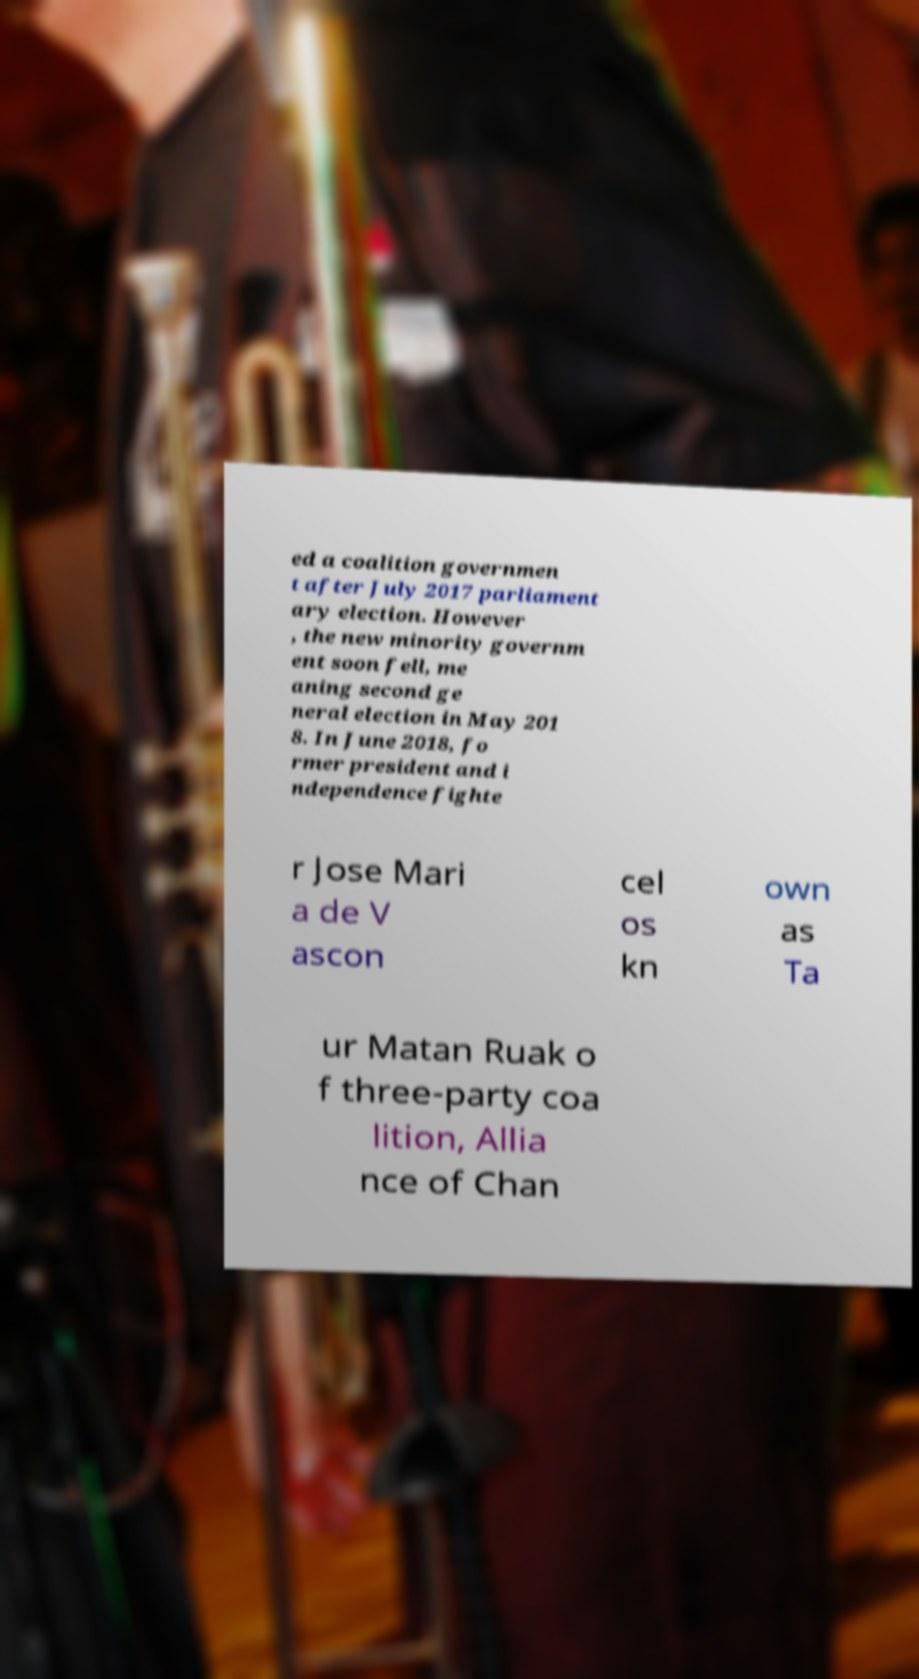What messages or text are displayed in this image? I need them in a readable, typed format. ed a coalition governmen t after July 2017 parliament ary election. However , the new minority governm ent soon fell, me aning second ge neral election in May 201 8. In June 2018, fo rmer president and i ndependence fighte r Jose Mari a de V ascon cel os kn own as Ta ur Matan Ruak o f three-party coa lition, Allia nce of Chan 